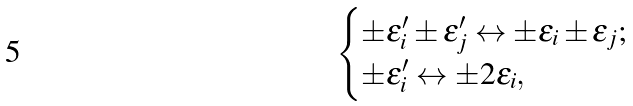Convert formula to latex. <formula><loc_0><loc_0><loc_500><loc_500>\begin{cases} \pm \epsilon ^ { \prime } _ { i } \pm \epsilon ^ { \prime } _ { j } \leftrightarrow \pm \epsilon _ { i } \pm \epsilon _ { j } ; \\ \pm \epsilon ^ { \prime } _ { i } \leftrightarrow \pm 2 \epsilon _ { i } , \end{cases}</formula> 